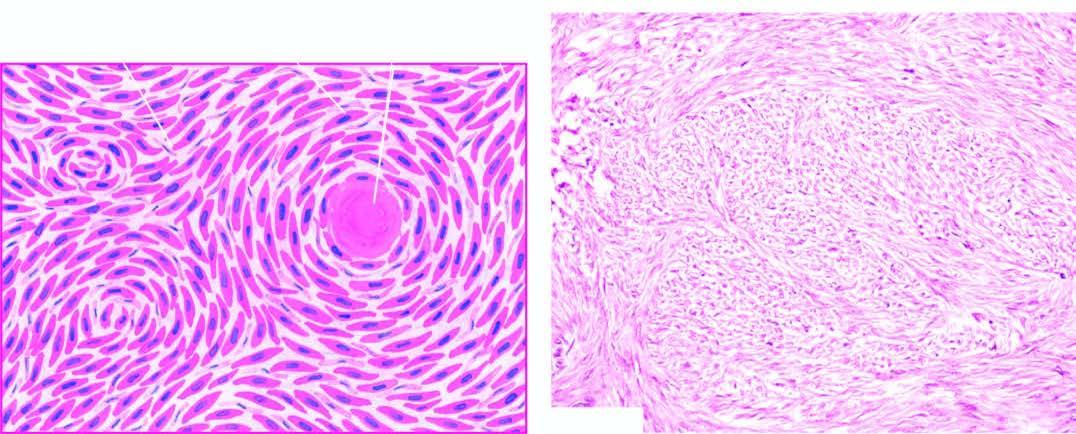does mucicarmine show whorls of smooth muscle cells which are spindle-shaped, having abundant cytoplasm and oval nuclei?
Answer the question using a single word or phrase. No 